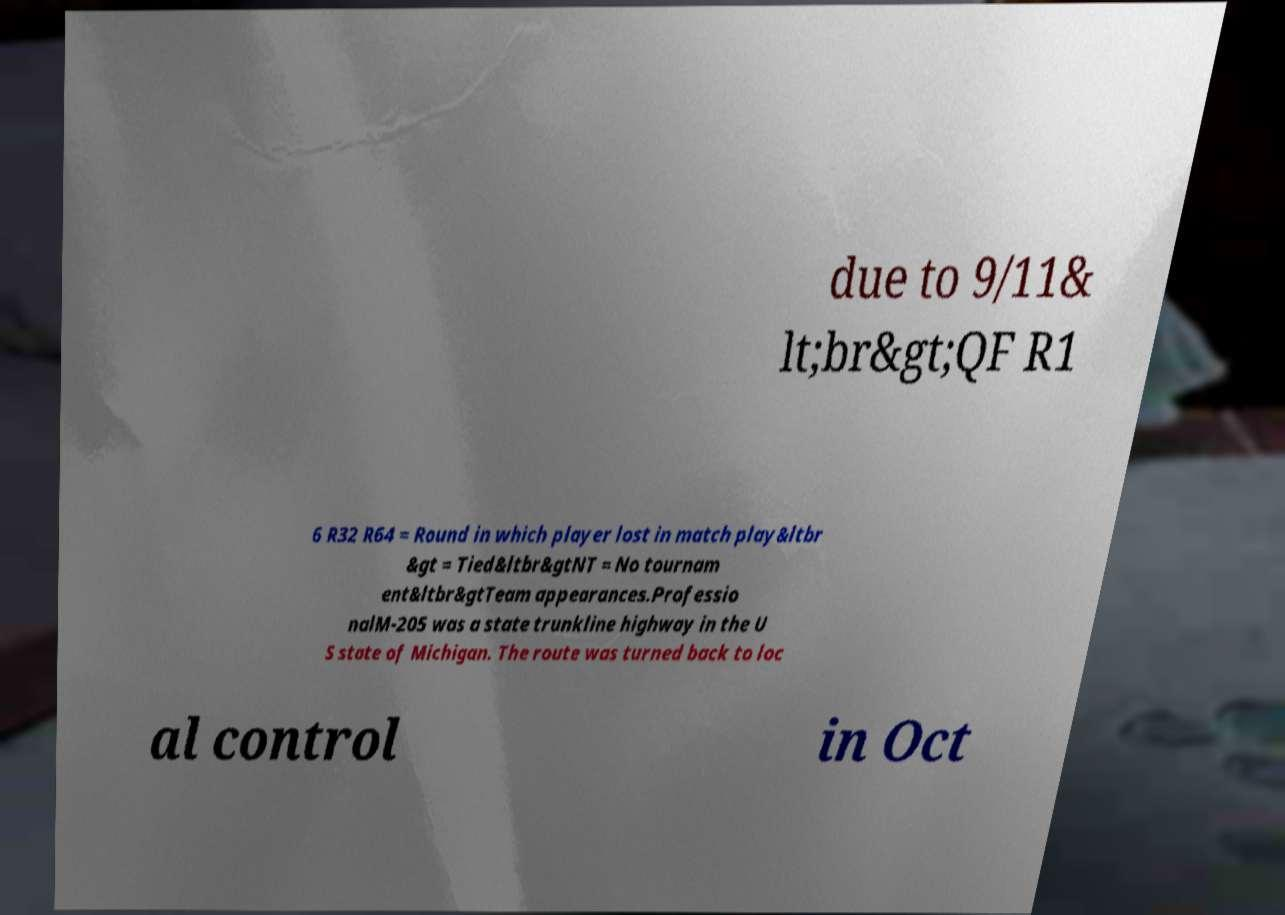Please identify and transcribe the text found in this image. due to 9/11& lt;br&gt;QF R1 6 R32 R64 = Round in which player lost in match play&ltbr &gt = Tied&ltbr&gtNT = No tournam ent&ltbr&gtTeam appearances.Professio nalM-205 was a state trunkline highway in the U S state of Michigan. The route was turned back to loc al control in Oct 